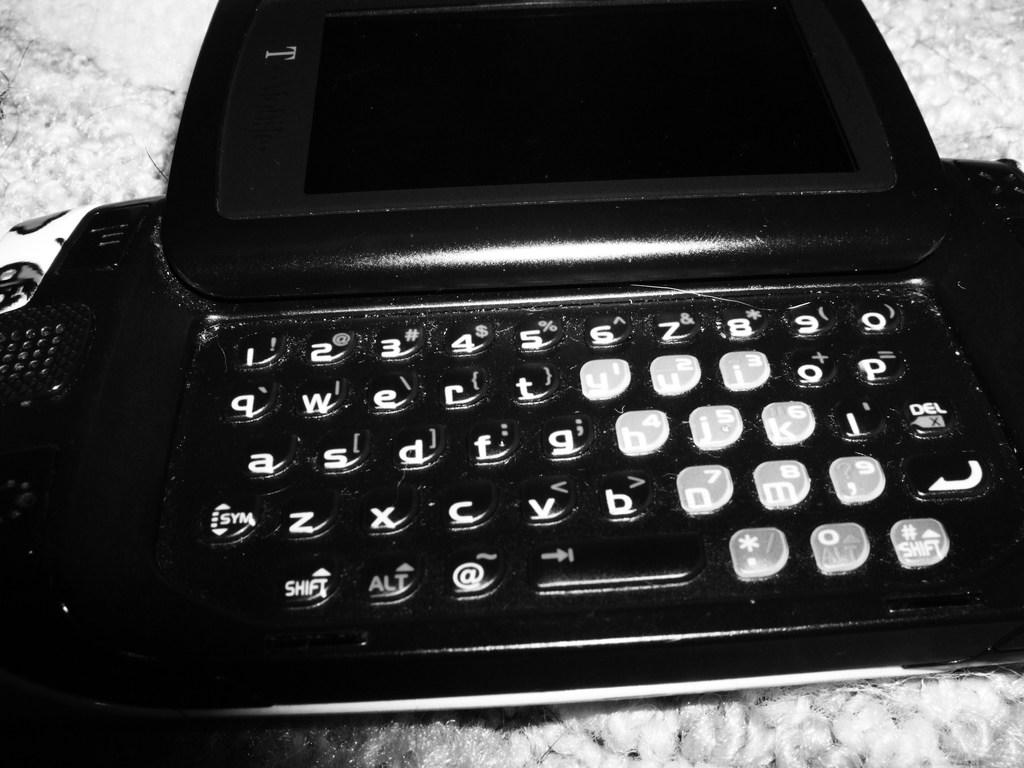<image>
Describe the image concisely. A black old fashioned typewriter type appliance with a T on the top. 